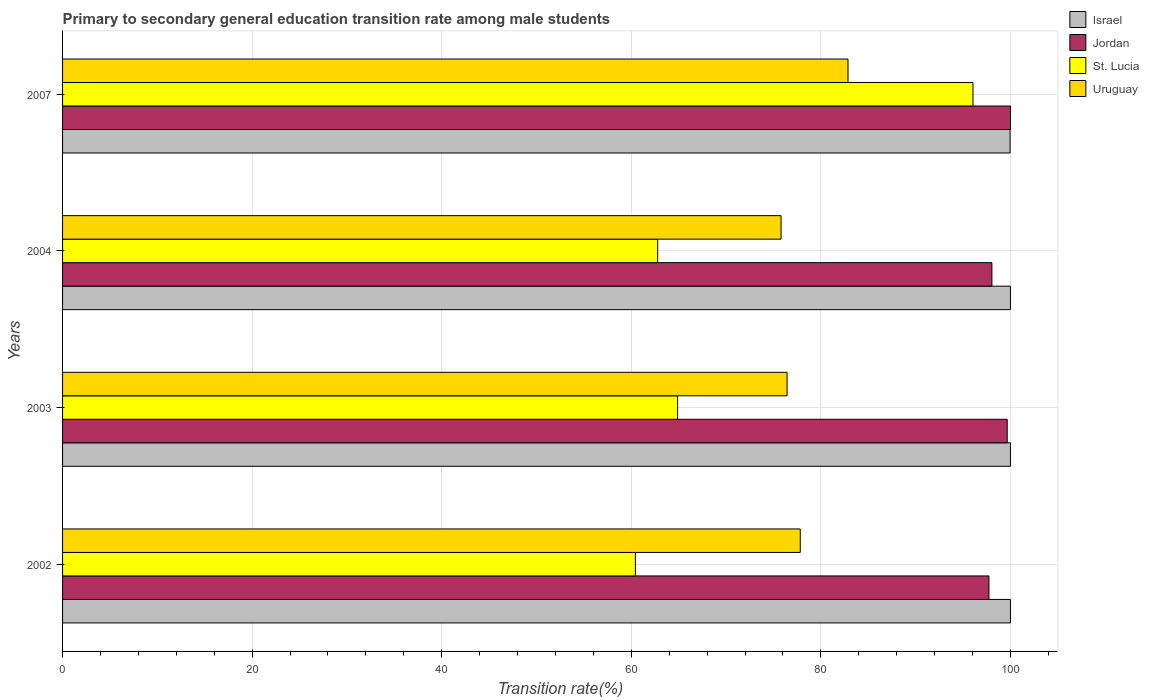Are the number of bars per tick equal to the number of legend labels?
Provide a short and direct response. Yes. How many bars are there on the 3rd tick from the bottom?
Your answer should be very brief. 4. What is the label of the 2nd group of bars from the top?
Your answer should be very brief. 2004. What is the transition rate in Israel in 2007?
Your answer should be compact. 99.96. Across all years, what is the maximum transition rate in St. Lucia?
Offer a terse response. 96.05. Across all years, what is the minimum transition rate in Israel?
Your answer should be compact. 99.96. What is the total transition rate in Jordan in the graph?
Your answer should be compact. 395.44. What is the difference between the transition rate in St. Lucia in 2003 and that in 2004?
Give a very brief answer. 2.1. What is the difference between the transition rate in Jordan in 2003 and the transition rate in Israel in 2002?
Provide a short and direct response. -0.34. What is the average transition rate in Uruguay per year?
Your answer should be compact. 78.23. In the year 2003, what is the difference between the transition rate in St. Lucia and transition rate in Uruguay?
Your answer should be compact. -11.55. In how many years, is the transition rate in Jordan greater than 68 %?
Give a very brief answer. 4. What is the ratio of the transition rate in St. Lucia in 2003 to that in 2004?
Provide a short and direct response. 1.03. Is the difference between the transition rate in St. Lucia in 2003 and 2007 greater than the difference between the transition rate in Uruguay in 2003 and 2007?
Make the answer very short. No. What is the difference between the highest and the second highest transition rate in Jordan?
Your answer should be very brief. 0.34. What is the difference between the highest and the lowest transition rate in Jordan?
Provide a short and direct response. 2.27. What does the 4th bar from the top in 2007 represents?
Provide a short and direct response. Israel. What does the 4th bar from the bottom in 2004 represents?
Your answer should be compact. Uruguay. Is it the case that in every year, the sum of the transition rate in Israel and transition rate in St. Lucia is greater than the transition rate in Uruguay?
Your response must be concise. Yes. How many bars are there?
Your response must be concise. 16. Are all the bars in the graph horizontal?
Provide a short and direct response. Yes. How many years are there in the graph?
Provide a short and direct response. 4. Does the graph contain grids?
Provide a short and direct response. Yes. How are the legend labels stacked?
Provide a short and direct response. Vertical. What is the title of the graph?
Your answer should be very brief. Primary to secondary general education transition rate among male students. Does "Isle of Man" appear as one of the legend labels in the graph?
Your answer should be compact. No. What is the label or title of the X-axis?
Offer a terse response. Transition rate(%). What is the Transition rate(%) in Jordan in 2002?
Offer a very short reply. 97.73. What is the Transition rate(%) of St. Lucia in 2002?
Your answer should be very brief. 60.43. What is the Transition rate(%) in Uruguay in 2002?
Offer a very short reply. 77.83. What is the Transition rate(%) in Jordan in 2003?
Provide a short and direct response. 99.66. What is the Transition rate(%) of St. Lucia in 2003?
Your answer should be very brief. 64.89. What is the Transition rate(%) in Uruguay in 2003?
Give a very brief answer. 76.43. What is the Transition rate(%) in Jordan in 2004?
Make the answer very short. 98.04. What is the Transition rate(%) of St. Lucia in 2004?
Your response must be concise. 62.78. What is the Transition rate(%) of Uruguay in 2004?
Offer a terse response. 75.8. What is the Transition rate(%) of Israel in 2007?
Provide a succinct answer. 99.96. What is the Transition rate(%) in Jordan in 2007?
Provide a short and direct response. 100. What is the Transition rate(%) in St. Lucia in 2007?
Keep it short and to the point. 96.05. What is the Transition rate(%) of Uruguay in 2007?
Give a very brief answer. 82.86. Across all years, what is the maximum Transition rate(%) of Jordan?
Provide a short and direct response. 100. Across all years, what is the maximum Transition rate(%) in St. Lucia?
Your answer should be compact. 96.05. Across all years, what is the maximum Transition rate(%) of Uruguay?
Offer a very short reply. 82.86. Across all years, what is the minimum Transition rate(%) of Israel?
Provide a short and direct response. 99.96. Across all years, what is the minimum Transition rate(%) of Jordan?
Provide a short and direct response. 97.73. Across all years, what is the minimum Transition rate(%) in St. Lucia?
Offer a terse response. 60.43. Across all years, what is the minimum Transition rate(%) of Uruguay?
Provide a succinct answer. 75.8. What is the total Transition rate(%) in Israel in the graph?
Give a very brief answer. 399.96. What is the total Transition rate(%) in Jordan in the graph?
Keep it short and to the point. 395.44. What is the total Transition rate(%) of St. Lucia in the graph?
Your answer should be compact. 284.15. What is the total Transition rate(%) of Uruguay in the graph?
Keep it short and to the point. 312.92. What is the difference between the Transition rate(%) of Jordan in 2002 and that in 2003?
Offer a terse response. -1.93. What is the difference between the Transition rate(%) of St. Lucia in 2002 and that in 2003?
Give a very brief answer. -4.45. What is the difference between the Transition rate(%) in Uruguay in 2002 and that in 2003?
Your response must be concise. 1.39. What is the difference between the Transition rate(%) in Jordan in 2002 and that in 2004?
Provide a succinct answer. -0.31. What is the difference between the Transition rate(%) of St. Lucia in 2002 and that in 2004?
Offer a very short reply. -2.35. What is the difference between the Transition rate(%) in Uruguay in 2002 and that in 2004?
Ensure brevity in your answer.  2.03. What is the difference between the Transition rate(%) of Israel in 2002 and that in 2007?
Ensure brevity in your answer.  0.04. What is the difference between the Transition rate(%) of Jordan in 2002 and that in 2007?
Your response must be concise. -2.27. What is the difference between the Transition rate(%) in St. Lucia in 2002 and that in 2007?
Provide a short and direct response. -35.61. What is the difference between the Transition rate(%) of Uruguay in 2002 and that in 2007?
Your answer should be compact. -5.04. What is the difference between the Transition rate(%) in Israel in 2003 and that in 2004?
Offer a terse response. 0. What is the difference between the Transition rate(%) of Jordan in 2003 and that in 2004?
Provide a succinct answer. 1.62. What is the difference between the Transition rate(%) in St. Lucia in 2003 and that in 2004?
Provide a succinct answer. 2.1. What is the difference between the Transition rate(%) in Uruguay in 2003 and that in 2004?
Provide a short and direct response. 0.63. What is the difference between the Transition rate(%) of Israel in 2003 and that in 2007?
Give a very brief answer. 0.04. What is the difference between the Transition rate(%) in Jordan in 2003 and that in 2007?
Your answer should be compact. -0.34. What is the difference between the Transition rate(%) of St. Lucia in 2003 and that in 2007?
Provide a short and direct response. -31.16. What is the difference between the Transition rate(%) in Uruguay in 2003 and that in 2007?
Keep it short and to the point. -6.43. What is the difference between the Transition rate(%) in Israel in 2004 and that in 2007?
Provide a short and direct response. 0.04. What is the difference between the Transition rate(%) of Jordan in 2004 and that in 2007?
Your response must be concise. -1.96. What is the difference between the Transition rate(%) in St. Lucia in 2004 and that in 2007?
Your response must be concise. -33.26. What is the difference between the Transition rate(%) of Uruguay in 2004 and that in 2007?
Give a very brief answer. -7.06. What is the difference between the Transition rate(%) in Israel in 2002 and the Transition rate(%) in Jordan in 2003?
Your answer should be compact. 0.34. What is the difference between the Transition rate(%) in Israel in 2002 and the Transition rate(%) in St. Lucia in 2003?
Offer a very short reply. 35.11. What is the difference between the Transition rate(%) in Israel in 2002 and the Transition rate(%) in Uruguay in 2003?
Your answer should be very brief. 23.57. What is the difference between the Transition rate(%) in Jordan in 2002 and the Transition rate(%) in St. Lucia in 2003?
Provide a succinct answer. 32.85. What is the difference between the Transition rate(%) of Jordan in 2002 and the Transition rate(%) of Uruguay in 2003?
Provide a succinct answer. 21.3. What is the difference between the Transition rate(%) of St. Lucia in 2002 and the Transition rate(%) of Uruguay in 2003?
Give a very brief answer. -16. What is the difference between the Transition rate(%) in Israel in 2002 and the Transition rate(%) in Jordan in 2004?
Offer a very short reply. 1.96. What is the difference between the Transition rate(%) of Israel in 2002 and the Transition rate(%) of St. Lucia in 2004?
Offer a terse response. 37.22. What is the difference between the Transition rate(%) in Israel in 2002 and the Transition rate(%) in Uruguay in 2004?
Your answer should be compact. 24.2. What is the difference between the Transition rate(%) of Jordan in 2002 and the Transition rate(%) of St. Lucia in 2004?
Your answer should be very brief. 34.95. What is the difference between the Transition rate(%) in Jordan in 2002 and the Transition rate(%) in Uruguay in 2004?
Offer a very short reply. 21.93. What is the difference between the Transition rate(%) of St. Lucia in 2002 and the Transition rate(%) of Uruguay in 2004?
Provide a short and direct response. -15.37. What is the difference between the Transition rate(%) in Israel in 2002 and the Transition rate(%) in St. Lucia in 2007?
Keep it short and to the point. 3.95. What is the difference between the Transition rate(%) in Israel in 2002 and the Transition rate(%) in Uruguay in 2007?
Provide a succinct answer. 17.14. What is the difference between the Transition rate(%) in Jordan in 2002 and the Transition rate(%) in St. Lucia in 2007?
Your answer should be compact. 1.69. What is the difference between the Transition rate(%) of Jordan in 2002 and the Transition rate(%) of Uruguay in 2007?
Ensure brevity in your answer.  14.87. What is the difference between the Transition rate(%) of St. Lucia in 2002 and the Transition rate(%) of Uruguay in 2007?
Keep it short and to the point. -22.43. What is the difference between the Transition rate(%) in Israel in 2003 and the Transition rate(%) in Jordan in 2004?
Your answer should be very brief. 1.96. What is the difference between the Transition rate(%) in Israel in 2003 and the Transition rate(%) in St. Lucia in 2004?
Offer a very short reply. 37.22. What is the difference between the Transition rate(%) in Israel in 2003 and the Transition rate(%) in Uruguay in 2004?
Give a very brief answer. 24.2. What is the difference between the Transition rate(%) of Jordan in 2003 and the Transition rate(%) of St. Lucia in 2004?
Give a very brief answer. 36.88. What is the difference between the Transition rate(%) in Jordan in 2003 and the Transition rate(%) in Uruguay in 2004?
Your answer should be very brief. 23.86. What is the difference between the Transition rate(%) of St. Lucia in 2003 and the Transition rate(%) of Uruguay in 2004?
Keep it short and to the point. -10.91. What is the difference between the Transition rate(%) of Israel in 2003 and the Transition rate(%) of Jordan in 2007?
Provide a succinct answer. 0. What is the difference between the Transition rate(%) of Israel in 2003 and the Transition rate(%) of St. Lucia in 2007?
Your response must be concise. 3.95. What is the difference between the Transition rate(%) in Israel in 2003 and the Transition rate(%) in Uruguay in 2007?
Your answer should be compact. 17.14. What is the difference between the Transition rate(%) in Jordan in 2003 and the Transition rate(%) in St. Lucia in 2007?
Offer a very short reply. 3.61. What is the difference between the Transition rate(%) of Jordan in 2003 and the Transition rate(%) of Uruguay in 2007?
Offer a terse response. 16.8. What is the difference between the Transition rate(%) of St. Lucia in 2003 and the Transition rate(%) of Uruguay in 2007?
Offer a terse response. -17.98. What is the difference between the Transition rate(%) in Israel in 2004 and the Transition rate(%) in Jordan in 2007?
Your answer should be very brief. 0. What is the difference between the Transition rate(%) of Israel in 2004 and the Transition rate(%) of St. Lucia in 2007?
Ensure brevity in your answer.  3.95. What is the difference between the Transition rate(%) in Israel in 2004 and the Transition rate(%) in Uruguay in 2007?
Your response must be concise. 17.14. What is the difference between the Transition rate(%) of Jordan in 2004 and the Transition rate(%) of St. Lucia in 2007?
Your answer should be very brief. 2. What is the difference between the Transition rate(%) in Jordan in 2004 and the Transition rate(%) in Uruguay in 2007?
Provide a short and direct response. 15.18. What is the difference between the Transition rate(%) in St. Lucia in 2004 and the Transition rate(%) in Uruguay in 2007?
Your answer should be compact. -20.08. What is the average Transition rate(%) in Israel per year?
Offer a terse response. 99.99. What is the average Transition rate(%) of Jordan per year?
Make the answer very short. 98.86. What is the average Transition rate(%) of St. Lucia per year?
Offer a very short reply. 71.04. What is the average Transition rate(%) of Uruguay per year?
Your answer should be compact. 78.23. In the year 2002, what is the difference between the Transition rate(%) of Israel and Transition rate(%) of Jordan?
Keep it short and to the point. 2.27. In the year 2002, what is the difference between the Transition rate(%) of Israel and Transition rate(%) of St. Lucia?
Offer a very short reply. 39.57. In the year 2002, what is the difference between the Transition rate(%) of Israel and Transition rate(%) of Uruguay?
Ensure brevity in your answer.  22.17. In the year 2002, what is the difference between the Transition rate(%) in Jordan and Transition rate(%) in St. Lucia?
Your answer should be very brief. 37.3. In the year 2002, what is the difference between the Transition rate(%) in Jordan and Transition rate(%) in Uruguay?
Your answer should be very brief. 19.91. In the year 2002, what is the difference between the Transition rate(%) in St. Lucia and Transition rate(%) in Uruguay?
Your answer should be very brief. -17.39. In the year 2003, what is the difference between the Transition rate(%) of Israel and Transition rate(%) of Jordan?
Ensure brevity in your answer.  0.34. In the year 2003, what is the difference between the Transition rate(%) of Israel and Transition rate(%) of St. Lucia?
Your response must be concise. 35.11. In the year 2003, what is the difference between the Transition rate(%) in Israel and Transition rate(%) in Uruguay?
Your answer should be very brief. 23.57. In the year 2003, what is the difference between the Transition rate(%) of Jordan and Transition rate(%) of St. Lucia?
Provide a succinct answer. 34.77. In the year 2003, what is the difference between the Transition rate(%) of Jordan and Transition rate(%) of Uruguay?
Provide a short and direct response. 23.23. In the year 2003, what is the difference between the Transition rate(%) in St. Lucia and Transition rate(%) in Uruguay?
Ensure brevity in your answer.  -11.55. In the year 2004, what is the difference between the Transition rate(%) of Israel and Transition rate(%) of Jordan?
Keep it short and to the point. 1.96. In the year 2004, what is the difference between the Transition rate(%) in Israel and Transition rate(%) in St. Lucia?
Make the answer very short. 37.22. In the year 2004, what is the difference between the Transition rate(%) of Israel and Transition rate(%) of Uruguay?
Your response must be concise. 24.2. In the year 2004, what is the difference between the Transition rate(%) in Jordan and Transition rate(%) in St. Lucia?
Keep it short and to the point. 35.26. In the year 2004, what is the difference between the Transition rate(%) of Jordan and Transition rate(%) of Uruguay?
Your answer should be compact. 22.24. In the year 2004, what is the difference between the Transition rate(%) in St. Lucia and Transition rate(%) in Uruguay?
Offer a very short reply. -13.02. In the year 2007, what is the difference between the Transition rate(%) of Israel and Transition rate(%) of Jordan?
Your answer should be compact. -0.04. In the year 2007, what is the difference between the Transition rate(%) of Israel and Transition rate(%) of St. Lucia?
Provide a succinct answer. 3.92. In the year 2007, what is the difference between the Transition rate(%) in Israel and Transition rate(%) in Uruguay?
Make the answer very short. 17.1. In the year 2007, what is the difference between the Transition rate(%) of Jordan and Transition rate(%) of St. Lucia?
Provide a short and direct response. 3.95. In the year 2007, what is the difference between the Transition rate(%) of Jordan and Transition rate(%) of Uruguay?
Provide a short and direct response. 17.14. In the year 2007, what is the difference between the Transition rate(%) of St. Lucia and Transition rate(%) of Uruguay?
Make the answer very short. 13.18. What is the ratio of the Transition rate(%) of Israel in 2002 to that in 2003?
Ensure brevity in your answer.  1. What is the ratio of the Transition rate(%) of Jordan in 2002 to that in 2003?
Ensure brevity in your answer.  0.98. What is the ratio of the Transition rate(%) of St. Lucia in 2002 to that in 2003?
Make the answer very short. 0.93. What is the ratio of the Transition rate(%) in Uruguay in 2002 to that in 2003?
Ensure brevity in your answer.  1.02. What is the ratio of the Transition rate(%) in St. Lucia in 2002 to that in 2004?
Make the answer very short. 0.96. What is the ratio of the Transition rate(%) in Uruguay in 2002 to that in 2004?
Your response must be concise. 1.03. What is the ratio of the Transition rate(%) of Israel in 2002 to that in 2007?
Your answer should be compact. 1. What is the ratio of the Transition rate(%) in Jordan in 2002 to that in 2007?
Your answer should be very brief. 0.98. What is the ratio of the Transition rate(%) of St. Lucia in 2002 to that in 2007?
Your response must be concise. 0.63. What is the ratio of the Transition rate(%) in Uruguay in 2002 to that in 2007?
Offer a terse response. 0.94. What is the ratio of the Transition rate(%) of Israel in 2003 to that in 2004?
Provide a short and direct response. 1. What is the ratio of the Transition rate(%) in Jordan in 2003 to that in 2004?
Provide a short and direct response. 1.02. What is the ratio of the Transition rate(%) of St. Lucia in 2003 to that in 2004?
Make the answer very short. 1.03. What is the ratio of the Transition rate(%) of Uruguay in 2003 to that in 2004?
Make the answer very short. 1.01. What is the ratio of the Transition rate(%) in Israel in 2003 to that in 2007?
Ensure brevity in your answer.  1. What is the ratio of the Transition rate(%) in St. Lucia in 2003 to that in 2007?
Make the answer very short. 0.68. What is the ratio of the Transition rate(%) in Uruguay in 2003 to that in 2007?
Make the answer very short. 0.92. What is the ratio of the Transition rate(%) of Israel in 2004 to that in 2007?
Offer a terse response. 1. What is the ratio of the Transition rate(%) in Jordan in 2004 to that in 2007?
Your answer should be compact. 0.98. What is the ratio of the Transition rate(%) of St. Lucia in 2004 to that in 2007?
Offer a very short reply. 0.65. What is the ratio of the Transition rate(%) in Uruguay in 2004 to that in 2007?
Offer a very short reply. 0.91. What is the difference between the highest and the second highest Transition rate(%) of Jordan?
Provide a short and direct response. 0.34. What is the difference between the highest and the second highest Transition rate(%) in St. Lucia?
Give a very brief answer. 31.16. What is the difference between the highest and the second highest Transition rate(%) of Uruguay?
Keep it short and to the point. 5.04. What is the difference between the highest and the lowest Transition rate(%) in Israel?
Your answer should be compact. 0.04. What is the difference between the highest and the lowest Transition rate(%) of Jordan?
Offer a very short reply. 2.27. What is the difference between the highest and the lowest Transition rate(%) in St. Lucia?
Keep it short and to the point. 35.61. What is the difference between the highest and the lowest Transition rate(%) in Uruguay?
Your response must be concise. 7.06. 